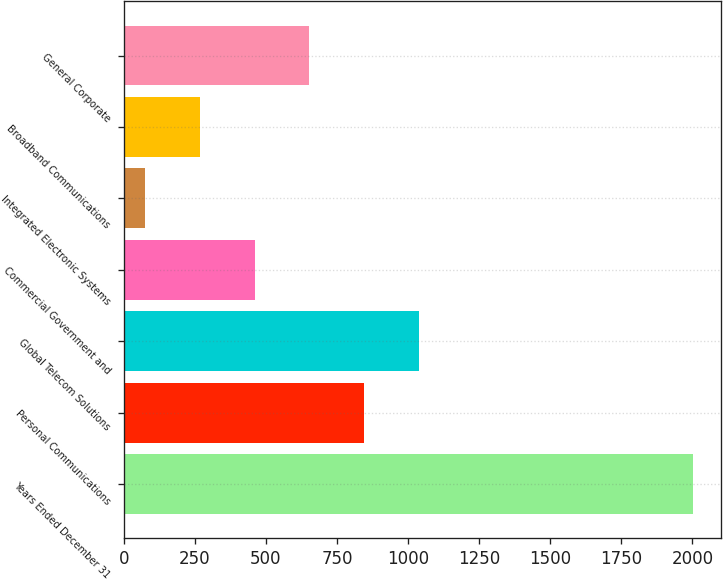<chart> <loc_0><loc_0><loc_500><loc_500><bar_chart><fcel>Years Ended December 31<fcel>Personal Communications<fcel>Global Telecom Solutions<fcel>Commercial Government and<fcel>Integrated Electronic Systems<fcel>Broadband Communications<fcel>General Corporate<nl><fcel>2002<fcel>845.8<fcel>1038.5<fcel>460.4<fcel>75<fcel>267.7<fcel>653.1<nl></chart> 